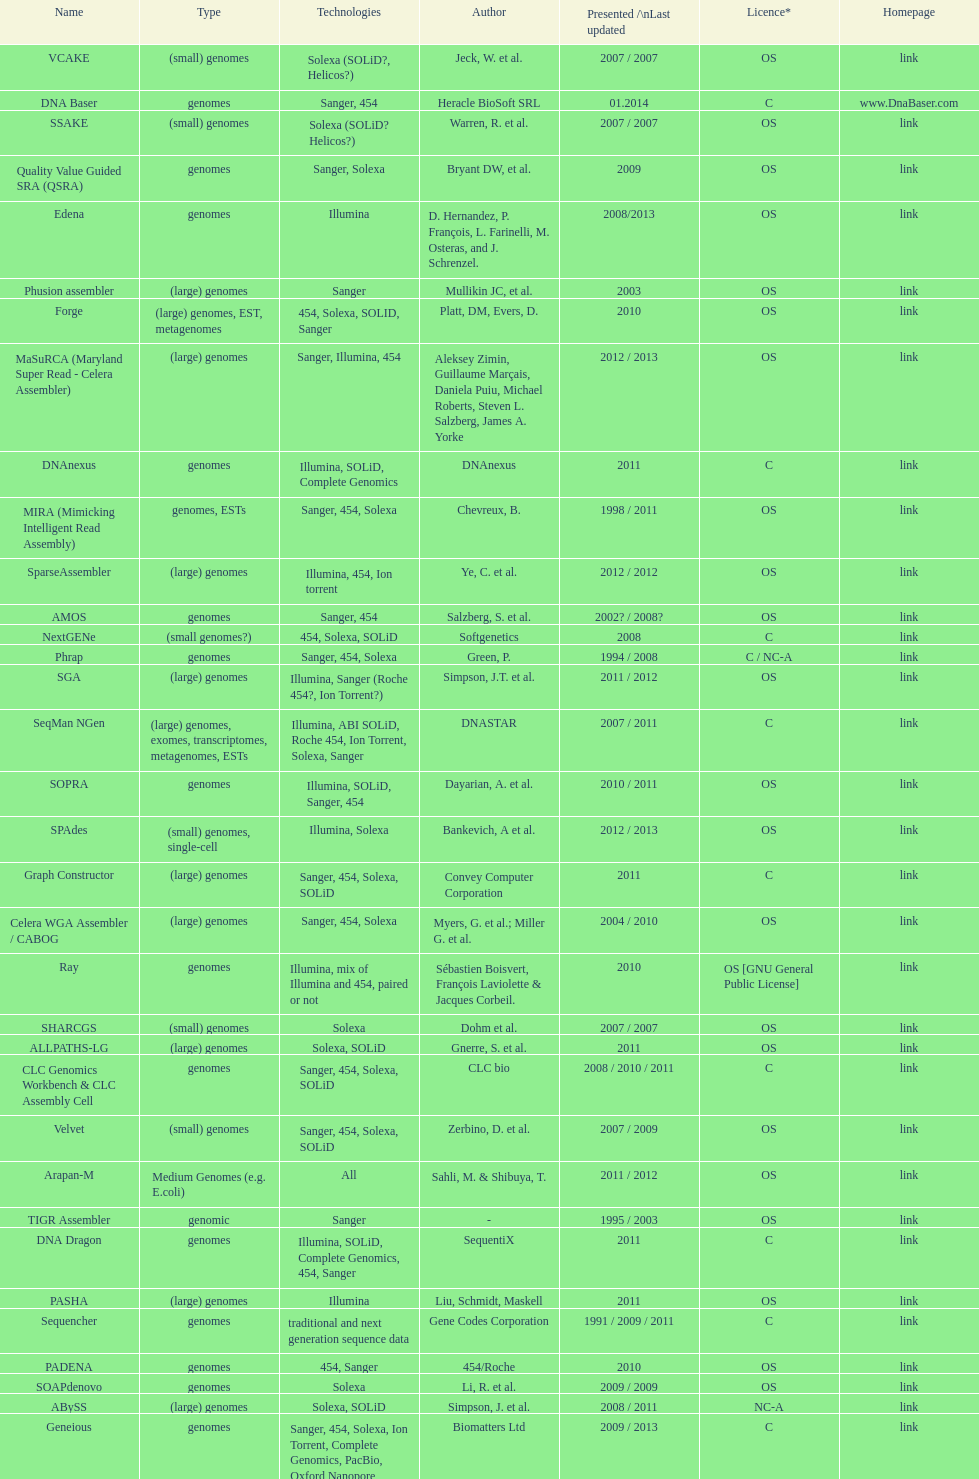When was the velvet last updated? 2009. 